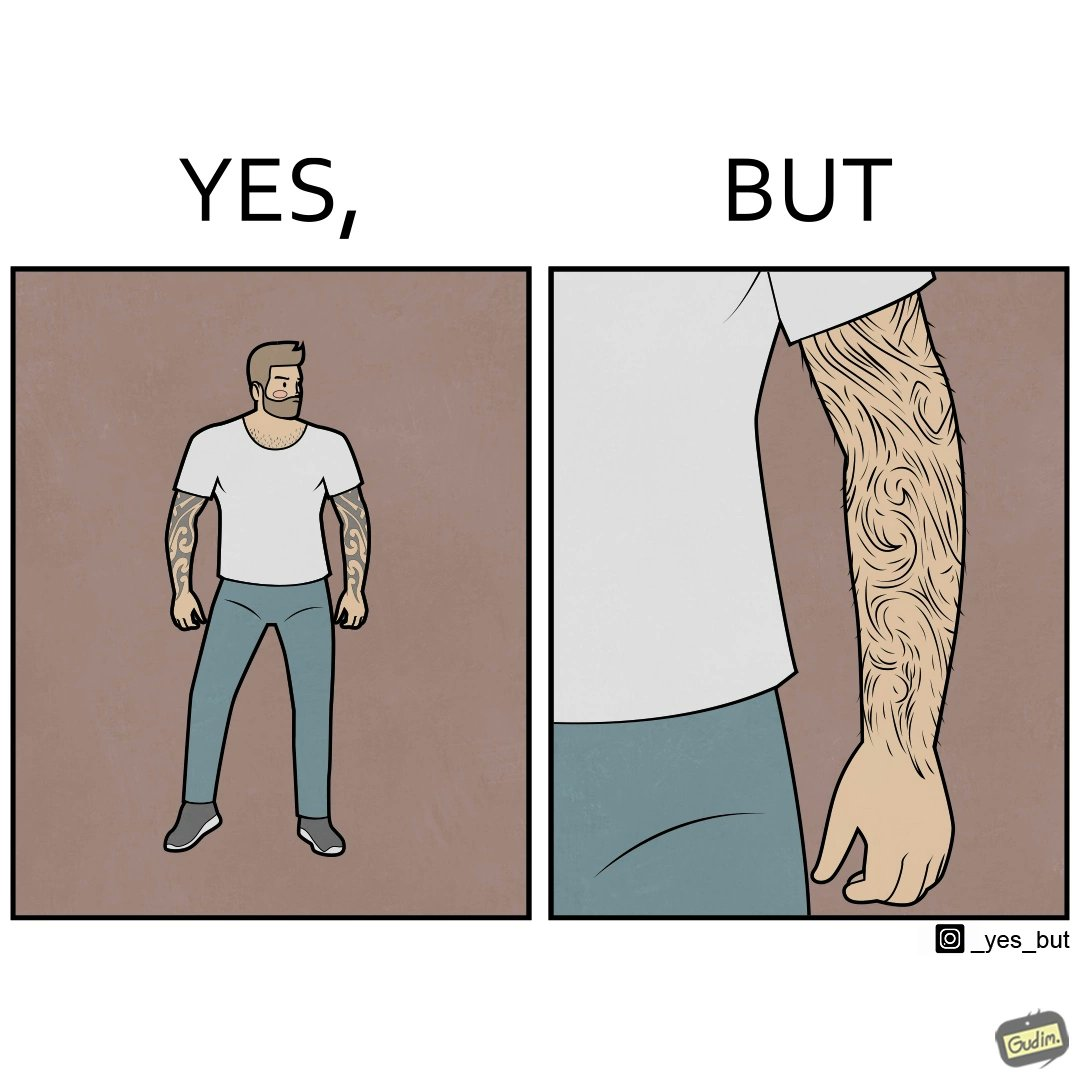Is this image satirical or non-satirical? Yes, this image is satirical. 